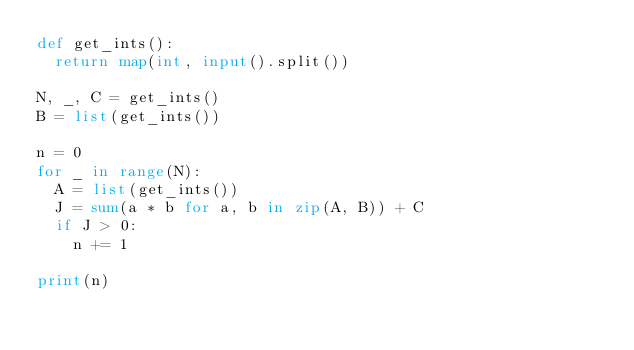Convert code to text. <code><loc_0><loc_0><loc_500><loc_500><_Python_>def get_ints():
  return map(int, input().split())

N, _, C = get_ints()
B = list(get_ints())

n = 0
for _ in range(N):
  A = list(get_ints())
  J = sum(a * b for a, b in zip(A, B)) + C
  if J > 0:
  	n += 1
    
print(n)
</code> 